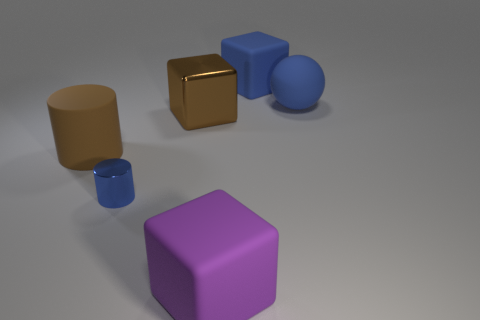There is a tiny metallic thing; is its shape the same as the big rubber object that is on the left side of the tiny blue cylinder? The tiny metallic thing has a cube shape which is identical to the shape of the large rubber object situated on the left side of the slender blue cylinder. 